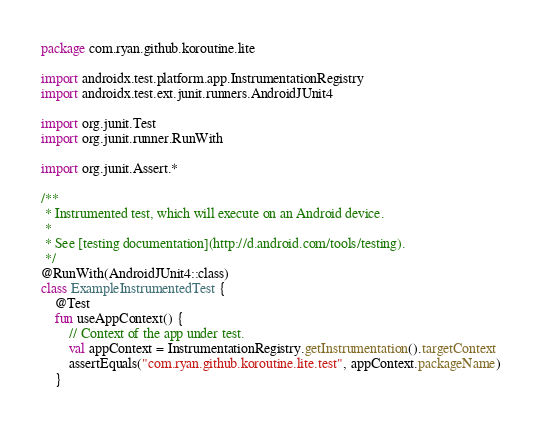Convert code to text. <code><loc_0><loc_0><loc_500><loc_500><_Kotlin_>package com.ryan.github.koroutine.lite

import androidx.test.platform.app.InstrumentationRegistry
import androidx.test.ext.junit.runners.AndroidJUnit4

import org.junit.Test
import org.junit.runner.RunWith

import org.junit.Assert.*

/**
 * Instrumented test, which will execute on an Android device.
 *
 * See [testing documentation](http://d.android.com/tools/testing).
 */
@RunWith(AndroidJUnit4::class)
class ExampleInstrumentedTest {
    @Test
    fun useAppContext() {
        // Context of the app under test.
        val appContext = InstrumentationRegistry.getInstrumentation().targetContext
        assertEquals("com.ryan.github.koroutine.lite.test", appContext.packageName)
    }</code> 